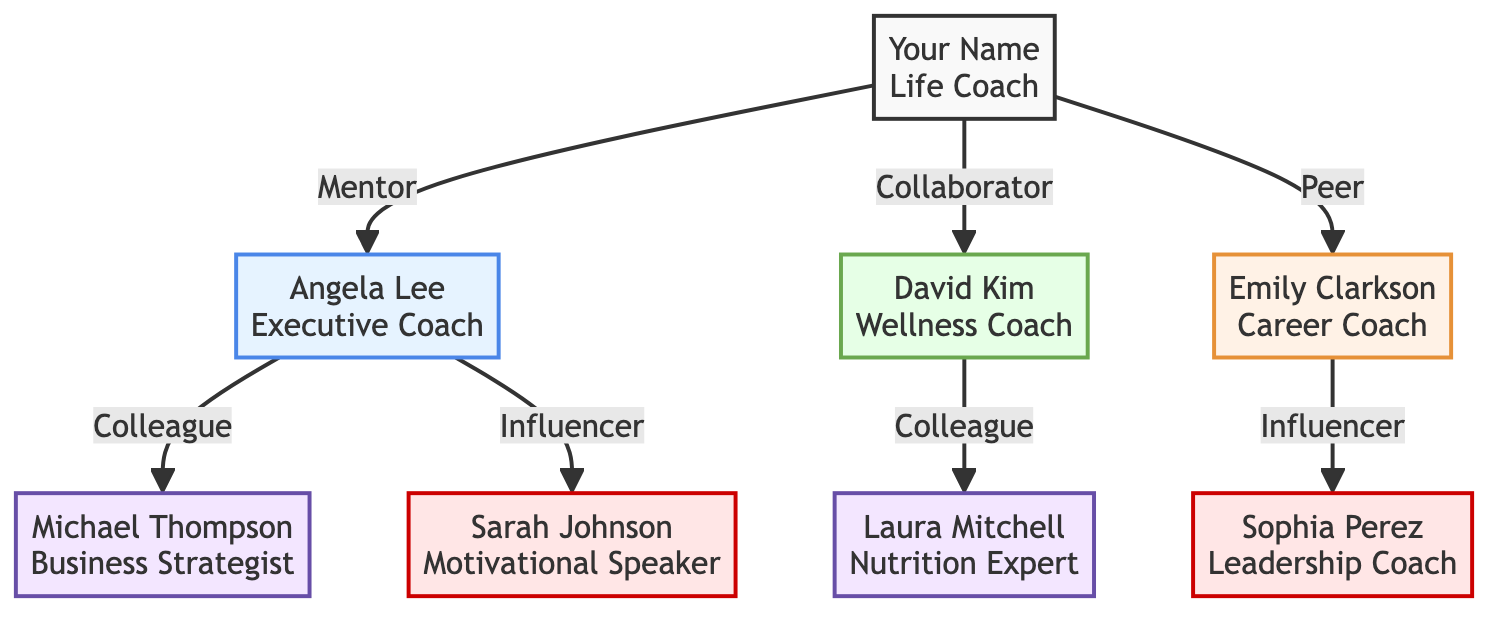What is the title of Your Name? The diagram indicates that "Your Name" is a "Life Coach." This can be seen directly next to their name in the diagram.
Answer: Life Coach How many connections does Angela Lee have? Angela Lee has two connections listed in the diagram, Michael Thompson and Sarah Johnson. They are indicated as the nodes directly connected to her node.
Answer: 2 What is the relationship between David Kim and Laura Mitchell? The diagram specifies that David Kim and Laura Mitchell have a "Colleague" relationship, shown by the label connecting their nodes.
Answer: Colleague Who is the influencer connected to Emily Clarkson? In the diagram, Sophia Perez is noted as the influencer connected to Emily Clarkson. This link is visible in the connections branching from Emily's node.
Answer: Sophia Perez What type of relationship does Your Name have with Angela Lee? According to the diagram, the relationship is labeled as "Mentor," which is displayed prominently between the two nodes representing Your Name and Angela Lee.
Answer: Mentor List one connection of Sarah Johnson. The diagram shows that Sarah Johnson does not have any connections listed. Hence, she stands as an independent node in this case.
Answer: None How many total nodes are present in the diagram? The diagram includes a total of 8 nodes: Your Name, Angela Lee, David Kim, Emily Clarkson, Michael Thompson, Sarah Johnson, Laura Mitchell, and Sophia Perez. Counting these nodes gives that total.
Answer: 8 Which type of relationship connects Your Name to David Kim? The relationship is labeled "Collaborator," which can be seen connecting Your Name's node directly to David Kim's node in the diagram.
Answer: Collaborator What is the title of Michael Thompson? The title displayed next to Michael Thompson in the diagram shows he is a "Business Strategist." This information is clearly indicated alongside his name.
Answer: Business Strategist 